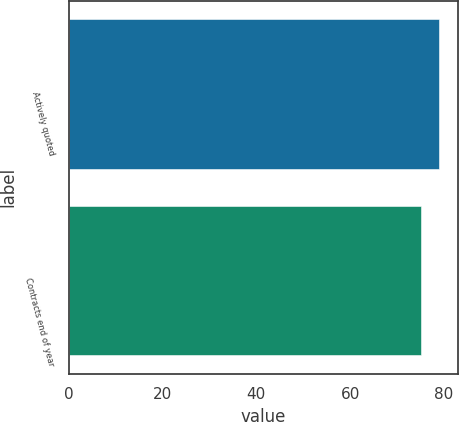Convert chart to OTSL. <chart><loc_0><loc_0><loc_500><loc_500><bar_chart><fcel>Actively quoted<fcel>Contracts end of year<nl><fcel>79<fcel>75<nl></chart> 